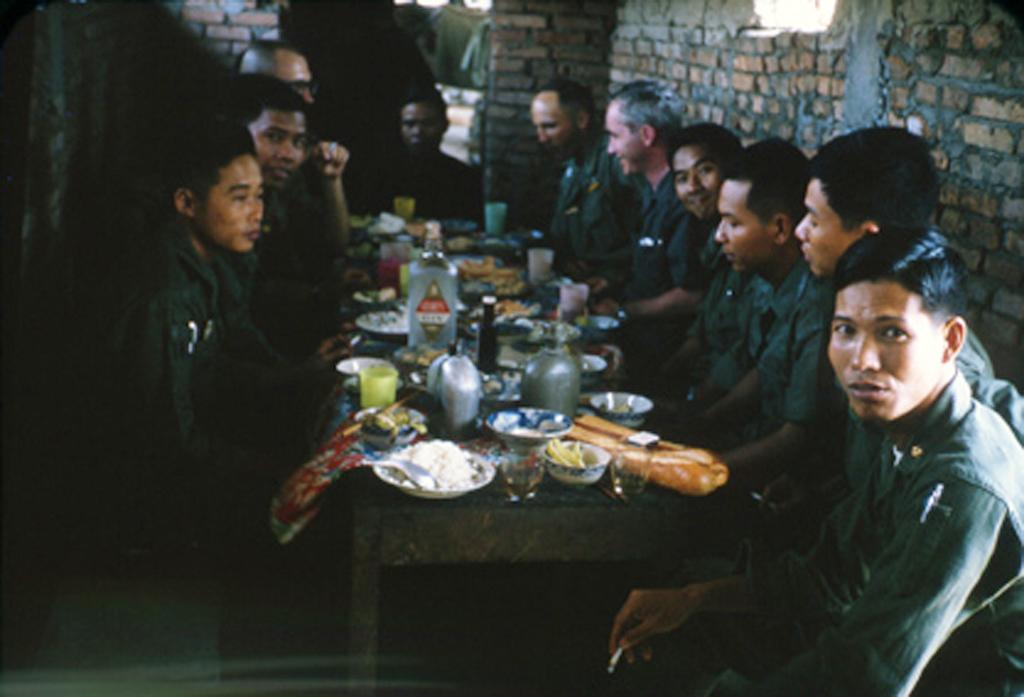What are the people in the image doing? The persons sitting around the table suggest they are engaged in a meal or gathering. What can be seen on the table besides the people? Beverage bottles, glasses, bowls, plates, and food are present on the table. What might be used for drinking in the image? Glasses are on the table, which might be used for drinking. What is the background of the image? There is a wall in the background of the image. What type of tank can be seen in the image? There is no tank present in the image; it features a group of people sitting around a table with various items. How many bananas are visible on the table? There is no banana present on the table in the image. 